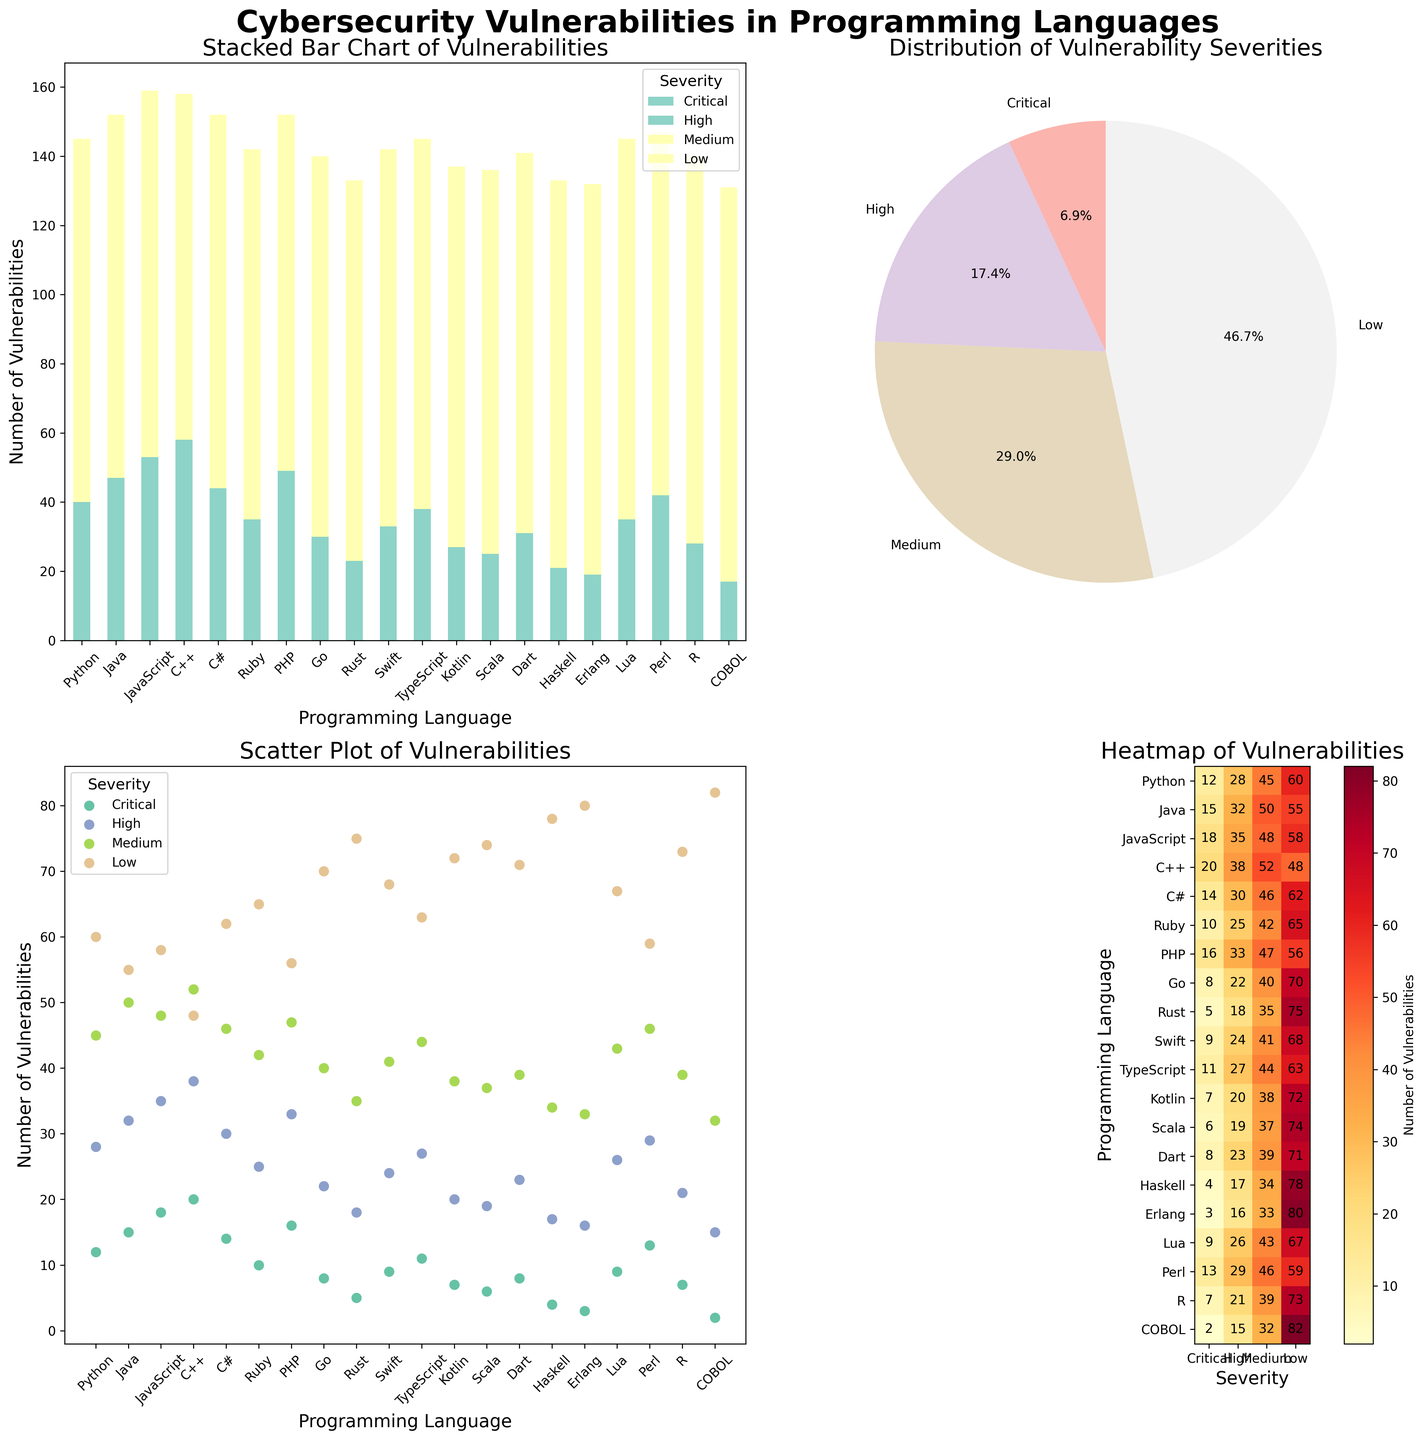What is the language with the highest number of Critical vulnerabilities? By looking at the stacked bar chart and the heatmap, we can see that C++ has the highest number of Critical vulnerabilities.
Answer: C++ Which language has a higher number of High vulnerabilities, Python or JavaScript? By comparing the height of the segments for Python and JavaScript in the stacked bar chart, and verifying the same on the heatmap, JavaScript has more High vulnerabilities than Python.
Answer: JavaScript What is the total number of vulnerabilities reported in Swift? From the heatmap or the bar chart, adding Critical (9), High (24), Medium (41), and Low (68) vulnerabilities gives 9+24+41+68 = 142.
Answer: 142 Which severity category has the highest percentage of vulnerabilities according to the pie chart? The pie chart shows that the Low severity category has the largest slice, indicating the highest percentage.
Answer: Low How do the Medium vulnerabilities in Kotlin compare to those in Dart? By comparing the height of the Medium segments in the stacked bar chart for Kotlin and Dart, both have 38 (Kotlin) and 39 (Dart), indicating Dart has one more Medium vulnerability than Kotlin.
Answer: Dart Identify the language with the lowest number of vulnerabilities in any category. Referring to the heatmap, COBOL has the lowest number of Critical vulnerabilities, which is 2.
Answer: COBOL Which language shows the highest number of Low severity vulnerabilities? From either the stacked bar chart or the heatmap, Erlang has the highest number of Low severity vulnerabilities with 80.
Answer: Erlang Among Java, C#, and PHP, which language has fewer High vulnerabilities? By comparing the heights of the High segments for Java (32), C# (30), and PHP (33) in the stacked bar chart, C# has the fewest High vulnerabilities.
Answer: C# What is the average number of Critical vulnerabilities for Python, PHP, Rust, and Scala combined? Summing the Critical vulnerabilities (Python: 12, PHP: 16, Rust: 5, Scala: 6) and then dividing by 4: (12+16+5+6) / 4 = 39 / 4 = 9.75.
Answer: 9.75 Which severity category is most evenly distributed across all languages? By looking at the stacked bar chart and the scatter plot, the Low severity shows relatively even distribution, with values spanning uniformly across all languages.
Answer: Low 